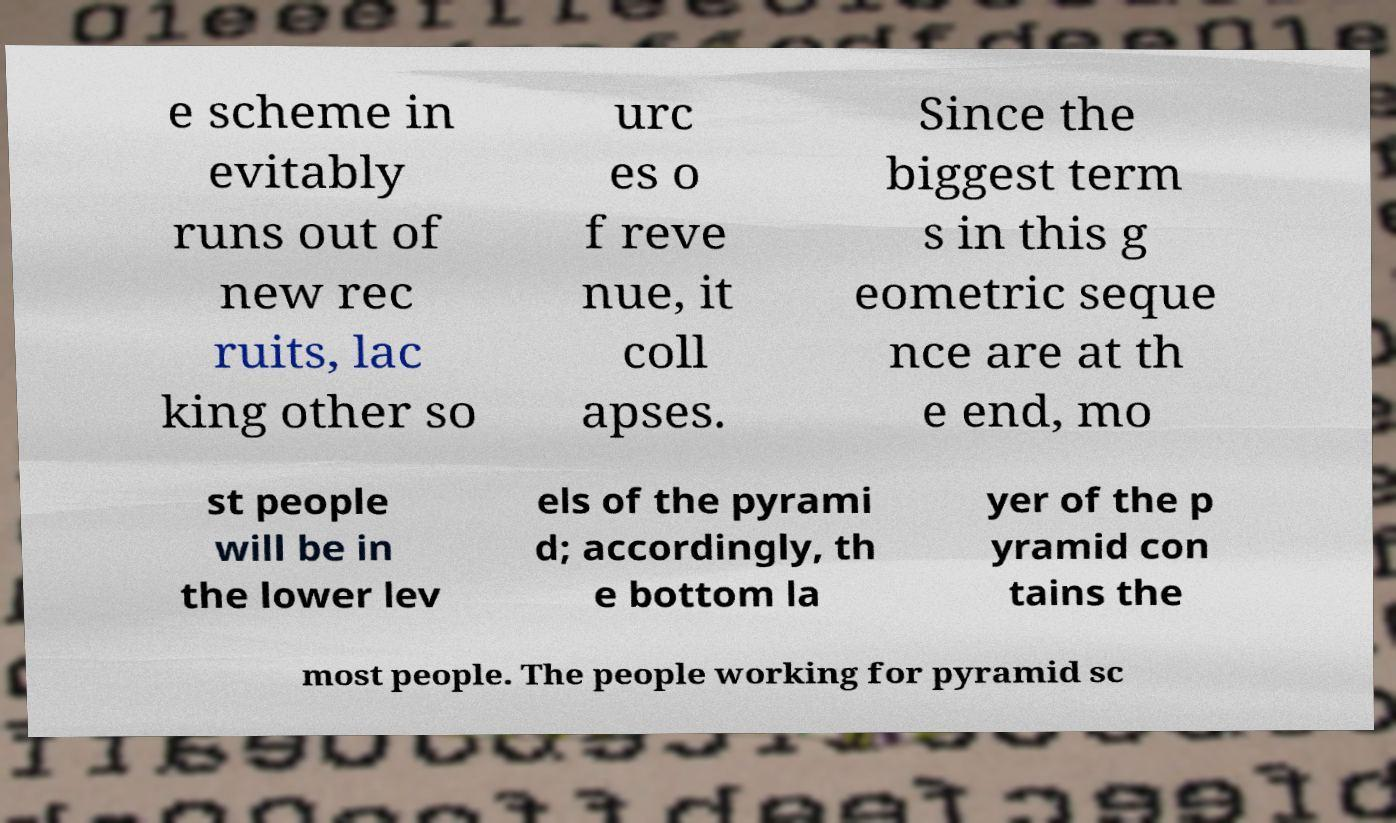For documentation purposes, I need the text within this image transcribed. Could you provide that? e scheme in evitably runs out of new rec ruits, lac king other so urc es o f reve nue, it coll apses. Since the biggest term s in this g eometric seque nce are at th e end, mo st people will be in the lower lev els of the pyrami d; accordingly, th e bottom la yer of the p yramid con tains the most people. The people working for pyramid sc 